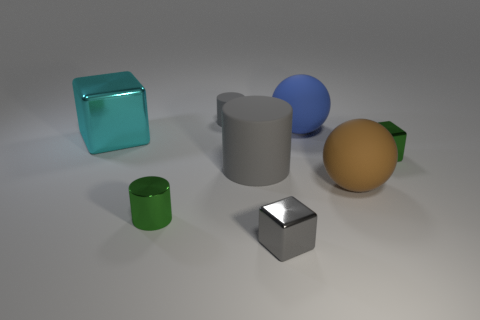Add 1 large gray things. How many objects exist? 9 Subtract all cylinders. How many objects are left? 5 Add 3 big brown rubber spheres. How many big brown rubber spheres are left? 4 Add 7 tiny green cylinders. How many tiny green cylinders exist? 8 Subtract 0 blue cylinders. How many objects are left? 8 Subtract all tiny yellow shiny cylinders. Subtract all tiny green cylinders. How many objects are left? 7 